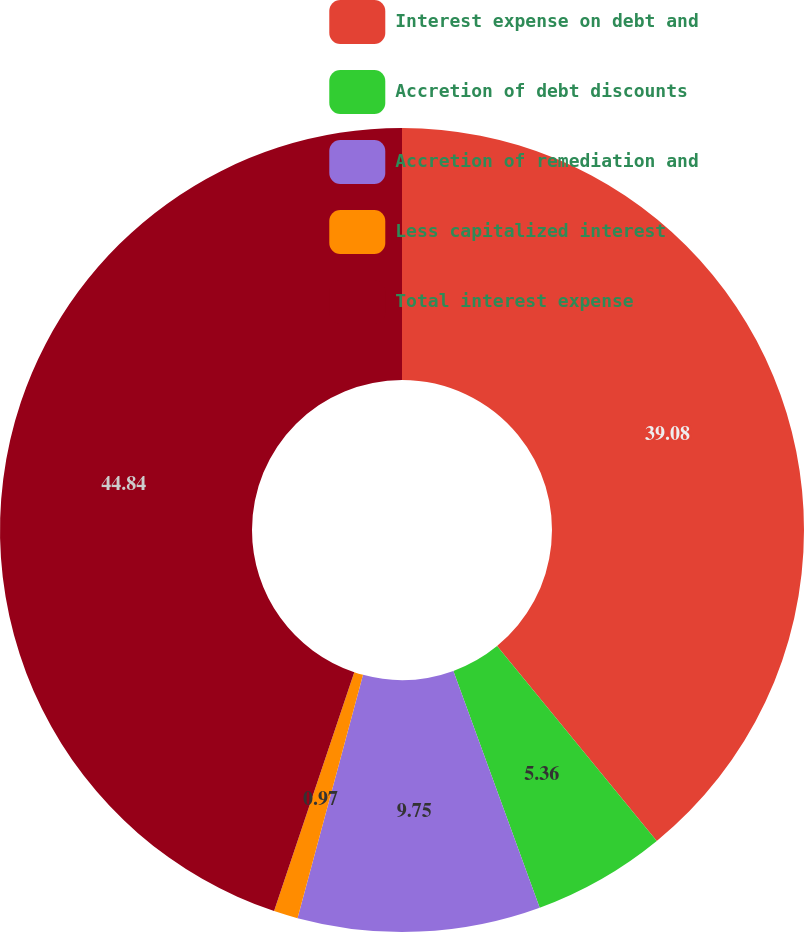Convert chart to OTSL. <chart><loc_0><loc_0><loc_500><loc_500><pie_chart><fcel>Interest expense on debt and<fcel>Accretion of debt discounts<fcel>Accretion of remediation and<fcel>Less capitalized interest<fcel>Total interest expense<nl><fcel>39.08%<fcel>5.36%<fcel>9.75%<fcel>0.97%<fcel>44.85%<nl></chart> 